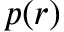<formula> <loc_0><loc_0><loc_500><loc_500>p ( r )</formula> 